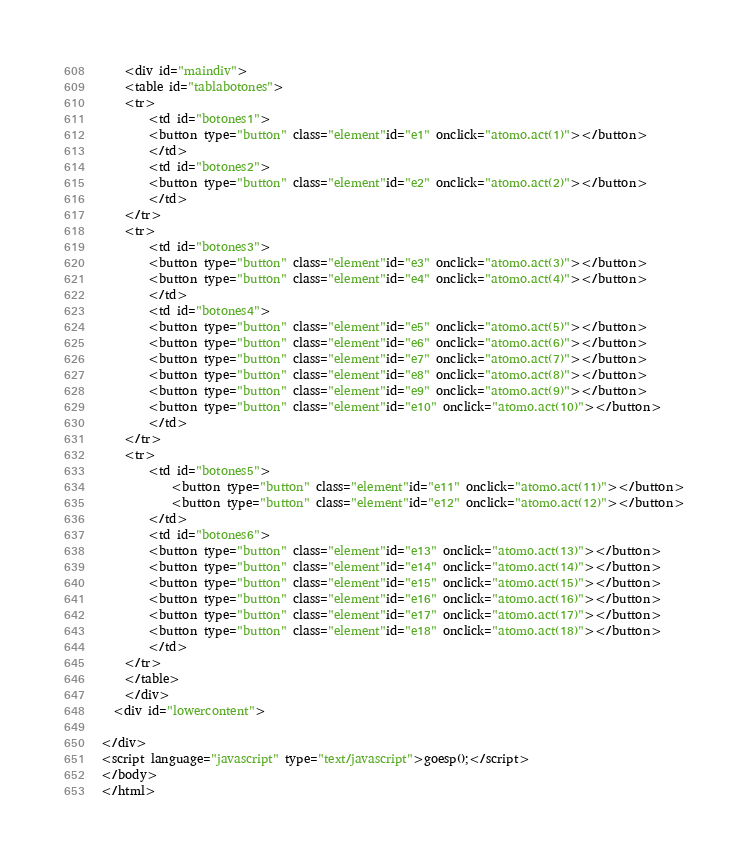<code> <loc_0><loc_0><loc_500><loc_500><_HTML_>
	<div id="maindiv">
	<table id="tablabotones">
	<tr>
		<td id="botones1">
		<button type="button" class="element"id="e1" onclick="atomo.act(1)"></button>
		</td>
		<td id="botones2">
		<button type="button" class="element"id="e2" onclick="atomo.act(2)"></button>
		</td>
	</tr>
	<tr>
		<td id="botones3">
		<button type="button" class="element"id="e3" onclick="atomo.act(3)"></button>
		<button type="button" class="element"id="e4" onclick="atomo.act(4)"></button>
		</td>
		<td id="botones4">
		<button type="button" class="element"id="e5" onclick="atomo.act(5)"></button>
		<button type="button" class="element"id="e6" onclick="atomo.act(6)"></button>
		<button type="button" class="element"id="e7" onclick="atomo.act(7)"></button>
		<button type="button" class="element"id="e8" onclick="atomo.act(8)"></button>
		<button type="button" class="element"id="e9" onclick="atomo.act(9)"></button>
		<button type="button" class="element"id="e10" onclick="atomo.act(10)"></button>
		</td>
	</tr>
	<tr>
		<td id="botones5">
		    <button type="button" class="element"id="e11" onclick="atomo.act(11)"></button>
		    <button type="button" class="element"id="e12" onclick="atomo.act(12)"></button>
		</td>
		<td id="botones6">
		<button type="button" class="element"id="e13" onclick="atomo.act(13)"></button>
		<button type="button" class="element"id="e14" onclick="atomo.act(14)"></button>
		<button type="button" class="element"id="e15" onclick="atomo.act(15)"></button>
		<button type="button" class="element"id="e16" onclick="atomo.act(16)"></button>
		<button type="button" class="element"id="e17" onclick="atomo.act(17)"></button>
		<button type="button" class="element"id="e18" onclick="atomo.act(18)"></button>
		</td>
	</tr>
	</table>
	</div>
  <div id="lowercontent">

</div>
<script language="javascript" type="text/javascript">goesp();</script>
</body>
</html>
</code> 